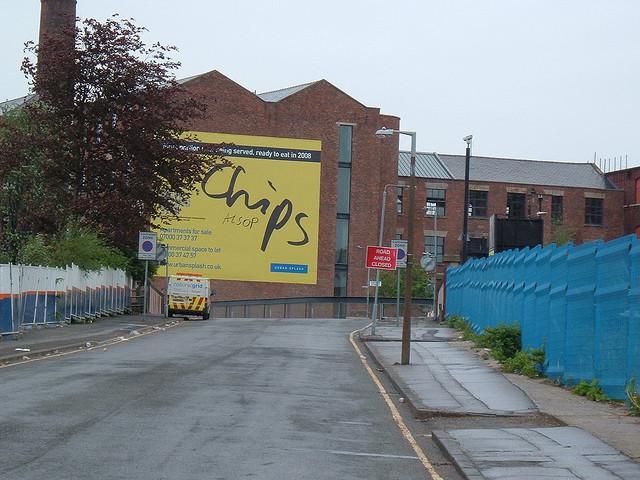What's the tall vertical structure on the left side of this photo?
Quick response, please. Chimney. What is the number of trees?
Quick response, please. 1. What does the yellow line on the street mean?
Quick response, please. Chips. What's the first color we see in the wall?
Quick response, please. Yellow. What color is the street sign?
Give a very brief answer. Red. What color is the satellite dish?
Be succinct. Gray. What color is the right-side fence?
Write a very short answer. Blue. What does the red sign say?
Keep it brief. Road ahead closed. What is the word on the sign in the middle of this scene?
Be succinct. Chips. 